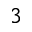<formula> <loc_0><loc_0><loc_500><loc_500>^ { 3 }</formula> 